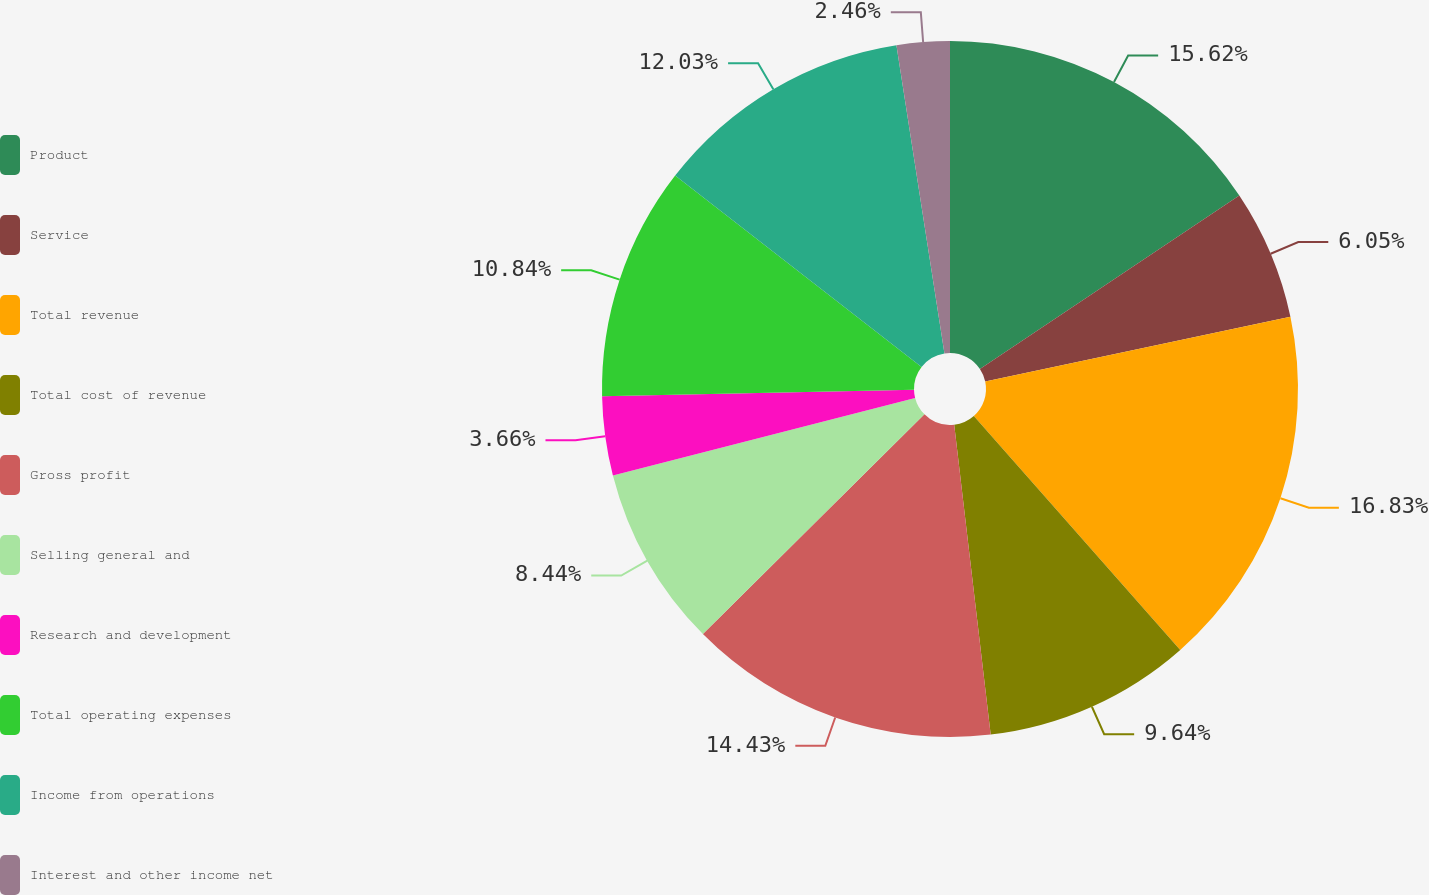Convert chart to OTSL. <chart><loc_0><loc_0><loc_500><loc_500><pie_chart><fcel>Product<fcel>Service<fcel>Total revenue<fcel>Total cost of revenue<fcel>Gross profit<fcel>Selling general and<fcel>Research and development<fcel>Total operating expenses<fcel>Income from operations<fcel>Interest and other income net<nl><fcel>15.62%<fcel>6.05%<fcel>16.82%<fcel>9.64%<fcel>14.43%<fcel>8.44%<fcel>3.66%<fcel>10.84%<fcel>12.03%<fcel>2.46%<nl></chart> 